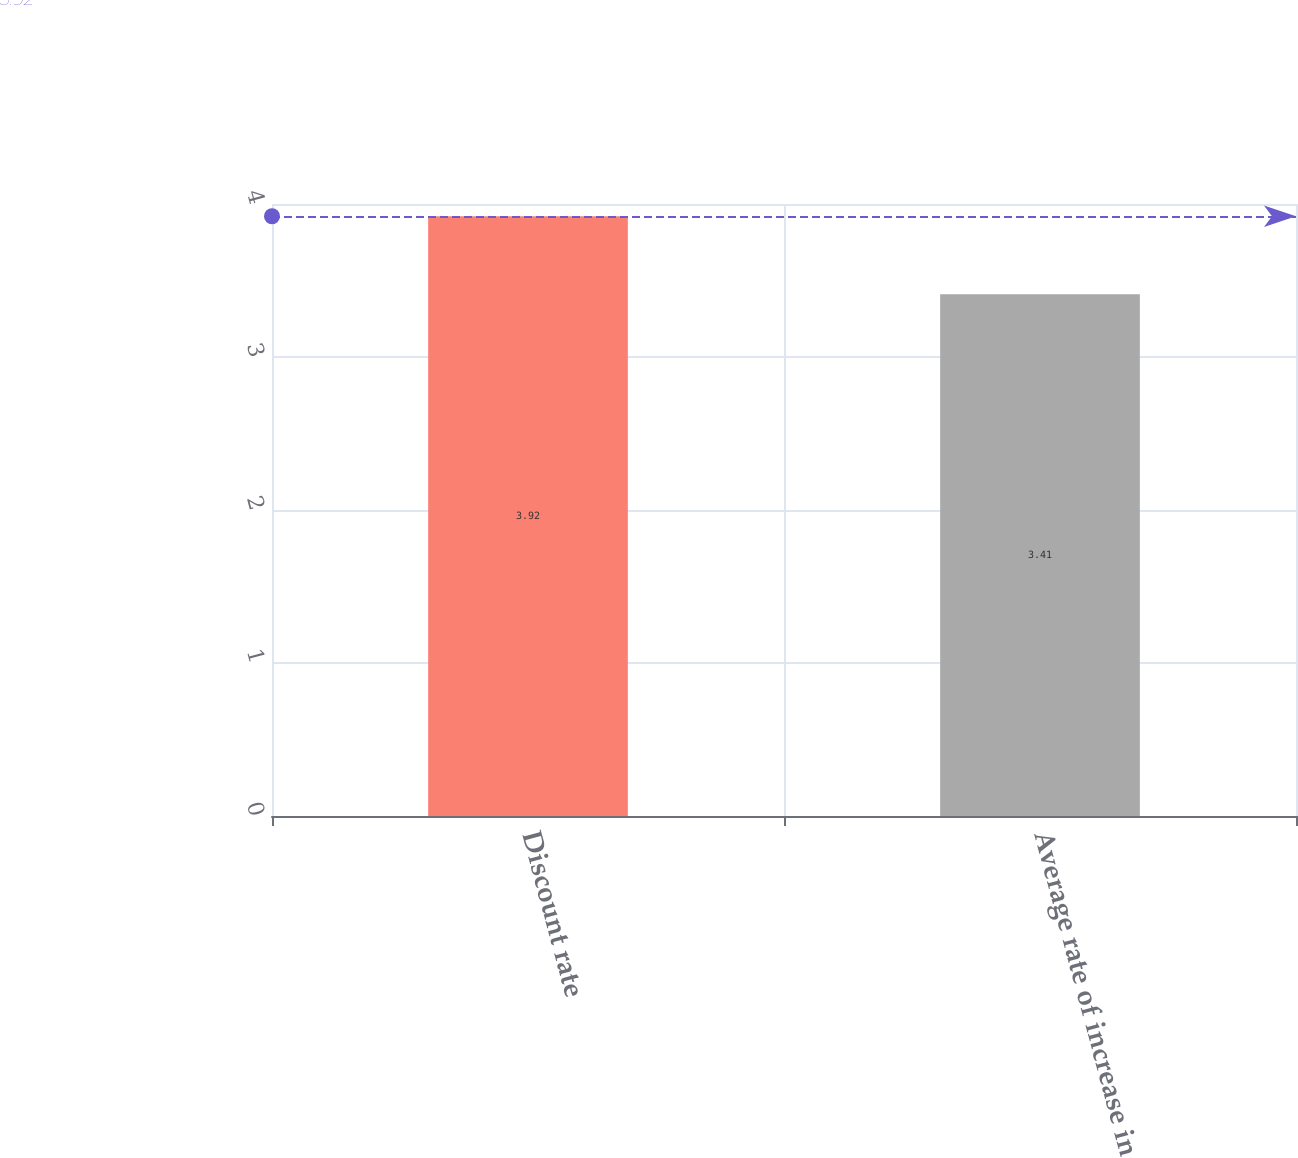<chart> <loc_0><loc_0><loc_500><loc_500><bar_chart><fcel>Discount rate<fcel>Average rate of increase in<nl><fcel>3.92<fcel>3.41<nl></chart> 